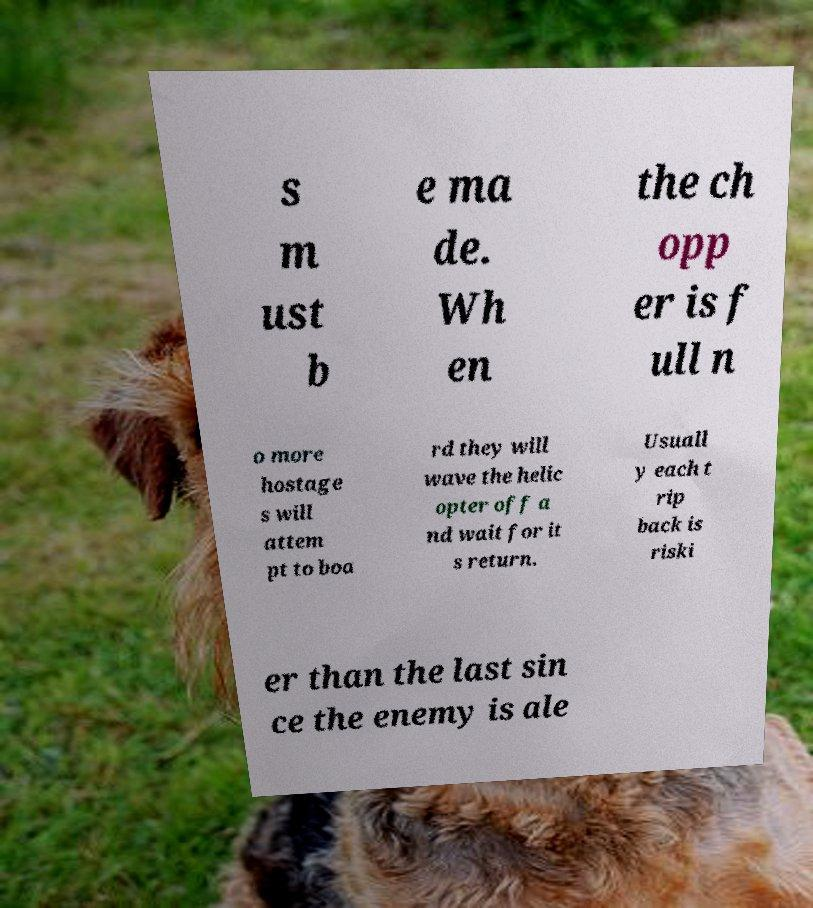Please identify and transcribe the text found in this image. s m ust b e ma de. Wh en the ch opp er is f ull n o more hostage s will attem pt to boa rd they will wave the helic opter off a nd wait for it s return. Usuall y each t rip back is riski er than the last sin ce the enemy is ale 